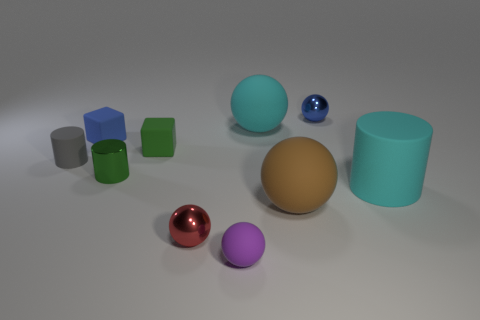Subtract all tiny metal spheres. How many spheres are left? 3 Subtract 2 cylinders. How many cylinders are left? 1 Subtract all blue cubes. How many cubes are left? 1 Add 4 big cylinders. How many big cylinders are left? 5 Add 4 large gray shiny things. How many large gray shiny things exist? 4 Subtract 1 green cylinders. How many objects are left? 9 Subtract all cylinders. How many objects are left? 7 Subtract all red blocks. Subtract all red cylinders. How many blocks are left? 2 Subtract all small balls. Subtract all tiny spheres. How many objects are left? 4 